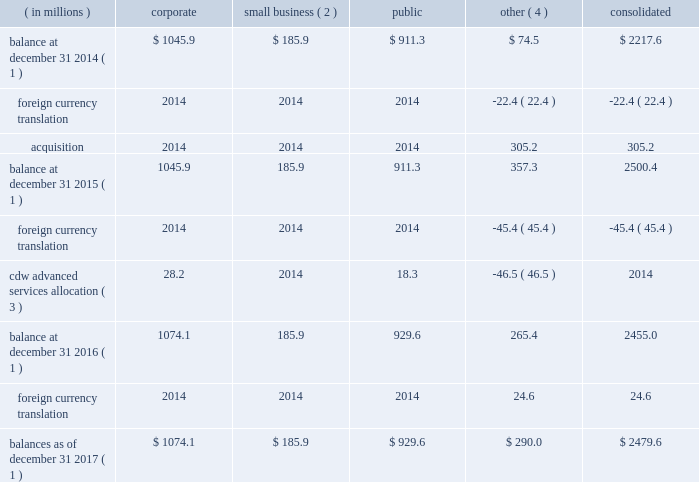Table of contents cdw corporation and subsidiaries 6 .
Goodwill and other intangible assets goodwill the changes in goodwill by reportable segment are as follows : ( in millions ) corporate business ( 2 ) public other ( 4 ) consolidated balance at december 31 , 2014 ( 1 ) $ 1045.9 $ 185.9 $ 911.3 $ 74.5 $ 2217.6 .
Balances as of december 31 , 2017 ( 1 ) $ 1074.1 $ 185.9 $ 929.6 $ 290.0 $ 2479.6 ( 1 ) goodwill is net of accumulated impairment losses of $ 1571 million , $ 354 million and $ 28 million related to the corporate , public and other segments , respectively .
( 2 ) amounts have been recast to present small business as its own operating and reportable segment .
( 3 ) effective january 1 , 2016 , the cdw advanced services business is included in the company's corporate and public segments .
( 4 ) other is comprised of canada and cdw uk operating segments .
With the establishment of small business as its own reporting unit , the company performed a quantitative analysis in order to allocate goodwill between corporate and small business .
Based on the results of the quantitative analysis performed as of january 1 , 2017 , the company determined that the fair values of corporate and small business reporting units exceeded their carrying values by 227% ( 227 % ) and 308% ( 308 % ) , respectively , and no impairment existed .
December 1 , 2017 impairment analysis the company completed its annual impairment analysis as of december 1 , 2017 .
For the corporate , small business and uk reporting units , the company performed a qualitative analysis .
The company determined that it was more-likely- than-not that the individual fair values of the corporate , small business and uk reporting units exceeded the respective carrying values and therefore a quantitative impairment analysis was deemed unnecessary .
Although uncertainty regarding the impact of the referendum on the uk 2019s membership of the european union ( 201ceu 201d ) , advising for the exit of the uk from the eu ( referred to as 201cbrexit 201d ) still exists in the current year , the company does not believe there to be any additional risk that would indicate the quantitative analysis performed in the prior year would have a different result .
Therefore , a qualitative analysis was deemed appropriate for the uk reporting unit .
The company performed a quantitative analysis of the public and canada reporting units .
Based on the results of the quantitative analysis , the company determined that the fair value of the public and canada reporting units exceeded their carrying values by 179% ( 179 % ) and 153% ( 153 % ) , respectively , and no impairment existed .
December 1 , 2016 impairment analysis the company completed its annual impairment analysis as of december 1 , 2016 .
For the corporate ( which , as of december 1 , 2016 , included small business ) , public and canada reporting units , the company performed a qualitative analysis .
The company determined that it was more-likely-than-not that the individual fair values of the corporate , public and canada reporting units exceeded the respective carrying values .
As a result of this determination , the quantitative impairment analysis was deemed unnecessary .
Due to the substantial uncertainty regarding the impact of brexit , the company performed a quantitative analysis of the cdw uk reporting unit .
Based on the results of the quantitative analysis , the company determined that the fair value of the cdw uk reporting unit exceeded its carrying value and no impairment existed. .
Public is what percent of the total goodwill balance at december 31 2014? 
Computations: (911.3 / 2217.6)
Answer: 0.41094. Table of contents cdw corporation and subsidiaries 6 .
Goodwill and other intangible assets goodwill the changes in goodwill by reportable segment are as follows : ( in millions ) corporate business ( 2 ) public other ( 4 ) consolidated balance at december 31 , 2014 ( 1 ) $ 1045.9 $ 185.9 $ 911.3 $ 74.5 $ 2217.6 .
Balances as of december 31 , 2017 ( 1 ) $ 1074.1 $ 185.9 $ 929.6 $ 290.0 $ 2479.6 ( 1 ) goodwill is net of accumulated impairment losses of $ 1571 million , $ 354 million and $ 28 million related to the corporate , public and other segments , respectively .
( 2 ) amounts have been recast to present small business as its own operating and reportable segment .
( 3 ) effective january 1 , 2016 , the cdw advanced services business is included in the company's corporate and public segments .
( 4 ) other is comprised of canada and cdw uk operating segments .
With the establishment of small business as its own reporting unit , the company performed a quantitative analysis in order to allocate goodwill between corporate and small business .
Based on the results of the quantitative analysis performed as of january 1 , 2017 , the company determined that the fair values of corporate and small business reporting units exceeded their carrying values by 227% ( 227 % ) and 308% ( 308 % ) , respectively , and no impairment existed .
December 1 , 2017 impairment analysis the company completed its annual impairment analysis as of december 1 , 2017 .
For the corporate , small business and uk reporting units , the company performed a qualitative analysis .
The company determined that it was more-likely- than-not that the individual fair values of the corporate , small business and uk reporting units exceeded the respective carrying values and therefore a quantitative impairment analysis was deemed unnecessary .
Although uncertainty regarding the impact of the referendum on the uk 2019s membership of the european union ( 201ceu 201d ) , advising for the exit of the uk from the eu ( referred to as 201cbrexit 201d ) still exists in the current year , the company does not believe there to be any additional risk that would indicate the quantitative analysis performed in the prior year would have a different result .
Therefore , a qualitative analysis was deemed appropriate for the uk reporting unit .
The company performed a quantitative analysis of the public and canada reporting units .
Based on the results of the quantitative analysis , the company determined that the fair value of the public and canada reporting units exceeded their carrying values by 179% ( 179 % ) and 153% ( 153 % ) , respectively , and no impairment existed .
December 1 , 2016 impairment analysis the company completed its annual impairment analysis as of december 1 , 2016 .
For the corporate ( which , as of december 1 , 2016 , included small business ) , public and canada reporting units , the company performed a qualitative analysis .
The company determined that it was more-likely-than-not that the individual fair values of the corporate , public and canada reporting units exceeded the respective carrying values .
As a result of this determination , the quantitative impairment analysis was deemed unnecessary .
Due to the substantial uncertainty regarding the impact of brexit , the company performed a quantitative analysis of the cdw uk reporting unit .
Based on the results of the quantitative analysis , the company determined that the fair value of the cdw uk reporting unit exceeded its carrying value and no impairment existed. .
Small business segment is what percent of the corporate goodwill balances as of december 31 2017? 
Computations: (185.9 / 1074.1)
Answer: 0.17308. 